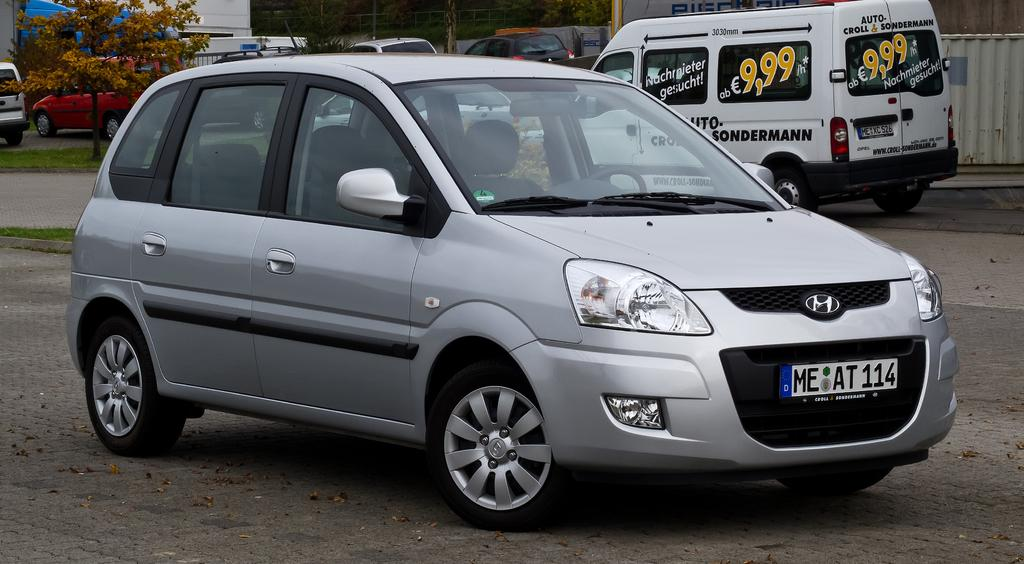What types of objects are on the ground in the image? There are vehicles on the ground in the image. What type of vegetation can be seen in the image? There is grass visible in the image. What other natural elements are present in the image? There are trees in the image. What structures are present in the image to control or direct movement? There is a barricade and a fence in the image. What type of man-made structure can be seen in the image? There is a building in the image. Can you see a rifle being used by someone in the image? There is no rifle present in the image. What type of key is used to unlock the cars in the image? There are no cars present in the image, so there is no need for a key to unlock them. 